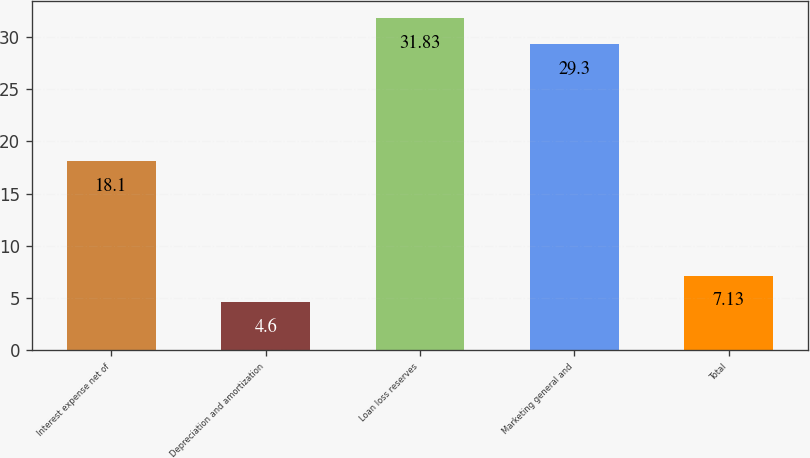<chart> <loc_0><loc_0><loc_500><loc_500><bar_chart><fcel>Interest expense net of<fcel>Depreciation and amortization<fcel>Loan loss reserves<fcel>Marketing general and<fcel>Total<nl><fcel>18.1<fcel>4.6<fcel>31.83<fcel>29.3<fcel>7.13<nl></chart> 